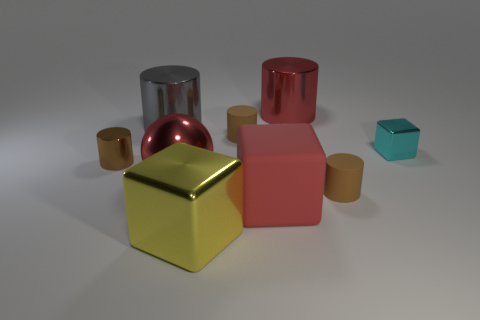Subtract all red balls. How many brown cylinders are left? 3 Subtract all gray cylinders. How many cylinders are left? 4 Subtract all red metal cylinders. How many cylinders are left? 4 Subtract 1 cylinders. How many cylinders are left? 4 Subtract all yellow cylinders. Subtract all cyan cubes. How many cylinders are left? 5 Subtract all cubes. How many objects are left? 6 Subtract 0 brown blocks. How many objects are left? 9 Subtract all cyan cubes. Subtract all red metallic objects. How many objects are left? 6 Add 7 tiny shiny cylinders. How many tiny shiny cylinders are left? 8 Add 9 small cyan metal objects. How many small cyan metal objects exist? 10 